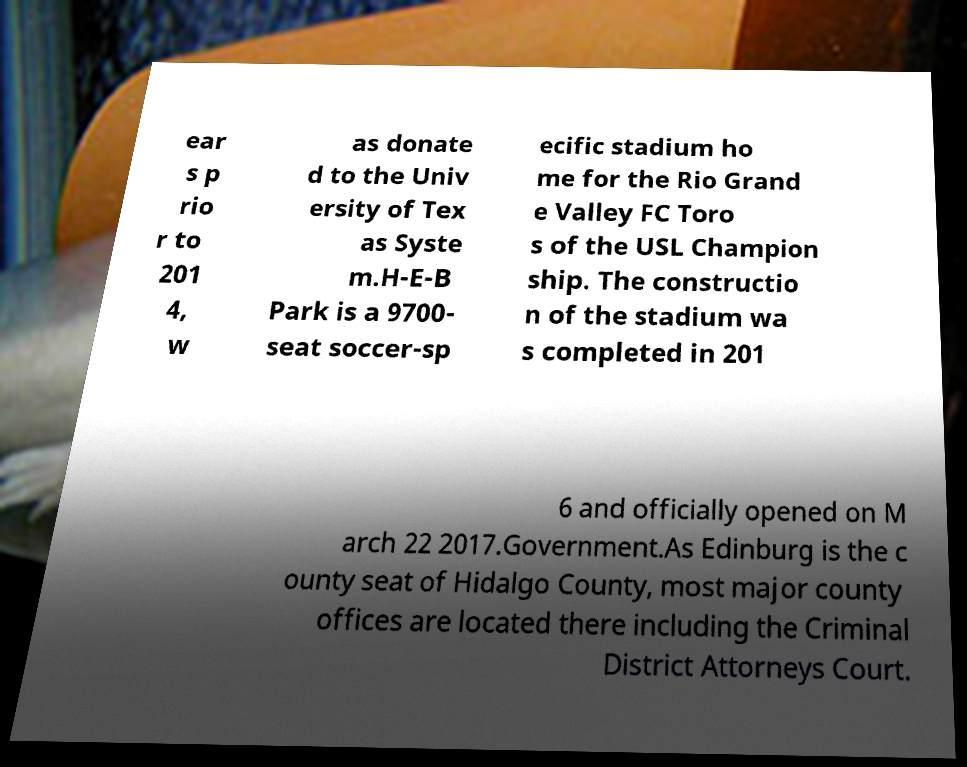Could you assist in decoding the text presented in this image and type it out clearly? ear s p rio r to 201 4, w as donate d to the Univ ersity of Tex as Syste m.H-E-B Park is a 9700- seat soccer-sp ecific stadium ho me for the Rio Grand e Valley FC Toro s of the USL Champion ship. The constructio n of the stadium wa s completed in 201 6 and officially opened on M arch 22 2017.Government.As Edinburg is the c ounty seat of Hidalgo County, most major county offices are located there including the Criminal District Attorneys Court. 